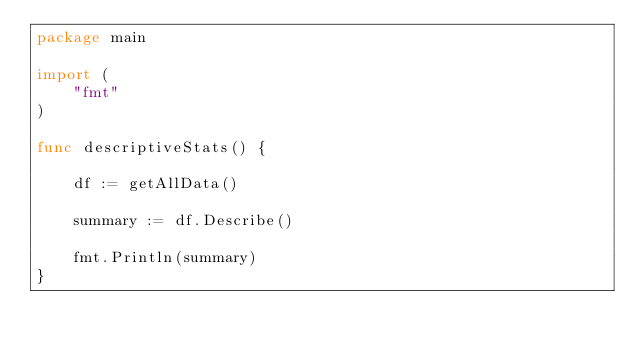<code> <loc_0><loc_0><loc_500><loc_500><_Go_>package main

import (
	"fmt"
)

func descriptiveStats() {

	df := getAllData()

	summary := df.Describe()

	fmt.Println(summary)
}
</code> 